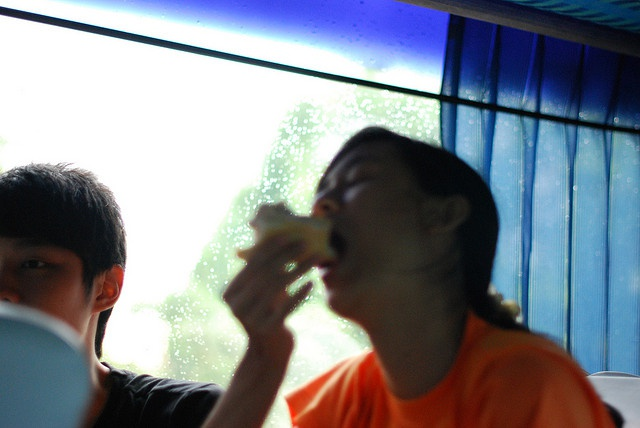Describe the objects in this image and their specific colors. I can see people in white, black, maroon, and ivory tones, people in white, black, maroon, gray, and darkgray tones, cup in white, gray, blue, and darkgray tones, and sandwich in white, black, and gray tones in this image. 